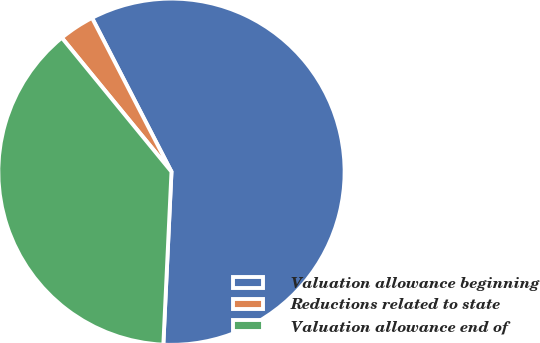Convert chart to OTSL. <chart><loc_0><loc_0><loc_500><loc_500><pie_chart><fcel>Valuation allowance beginning<fcel>Reductions related to state<fcel>Valuation allowance end of<nl><fcel>58.33%<fcel>3.33%<fcel>38.33%<nl></chart> 